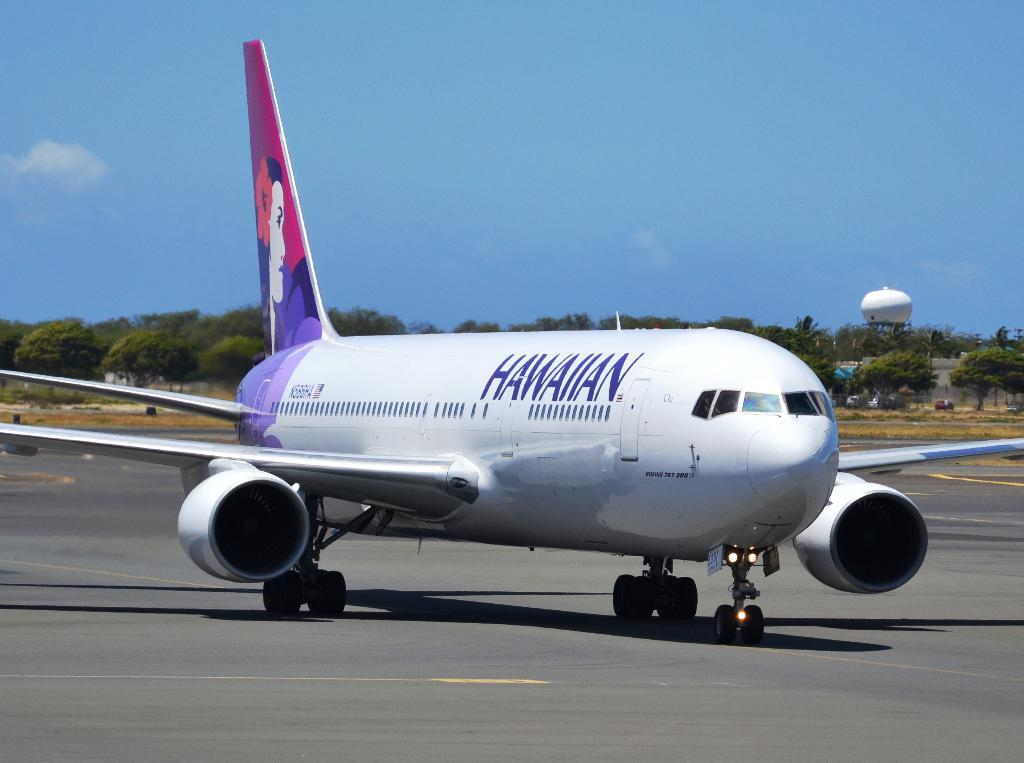Provide a one-sentence caption for the provided image. A Hawaiian air jet takes off from a run way. 